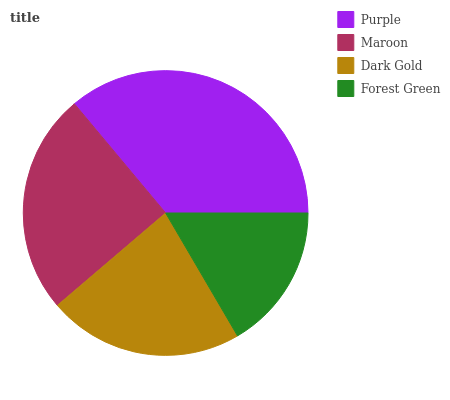Is Forest Green the minimum?
Answer yes or no. Yes. Is Purple the maximum?
Answer yes or no. Yes. Is Maroon the minimum?
Answer yes or no. No. Is Maroon the maximum?
Answer yes or no. No. Is Purple greater than Maroon?
Answer yes or no. Yes. Is Maroon less than Purple?
Answer yes or no. Yes. Is Maroon greater than Purple?
Answer yes or no. No. Is Purple less than Maroon?
Answer yes or no. No. Is Maroon the high median?
Answer yes or no. Yes. Is Dark Gold the low median?
Answer yes or no. Yes. Is Forest Green the high median?
Answer yes or no. No. Is Maroon the low median?
Answer yes or no. No. 